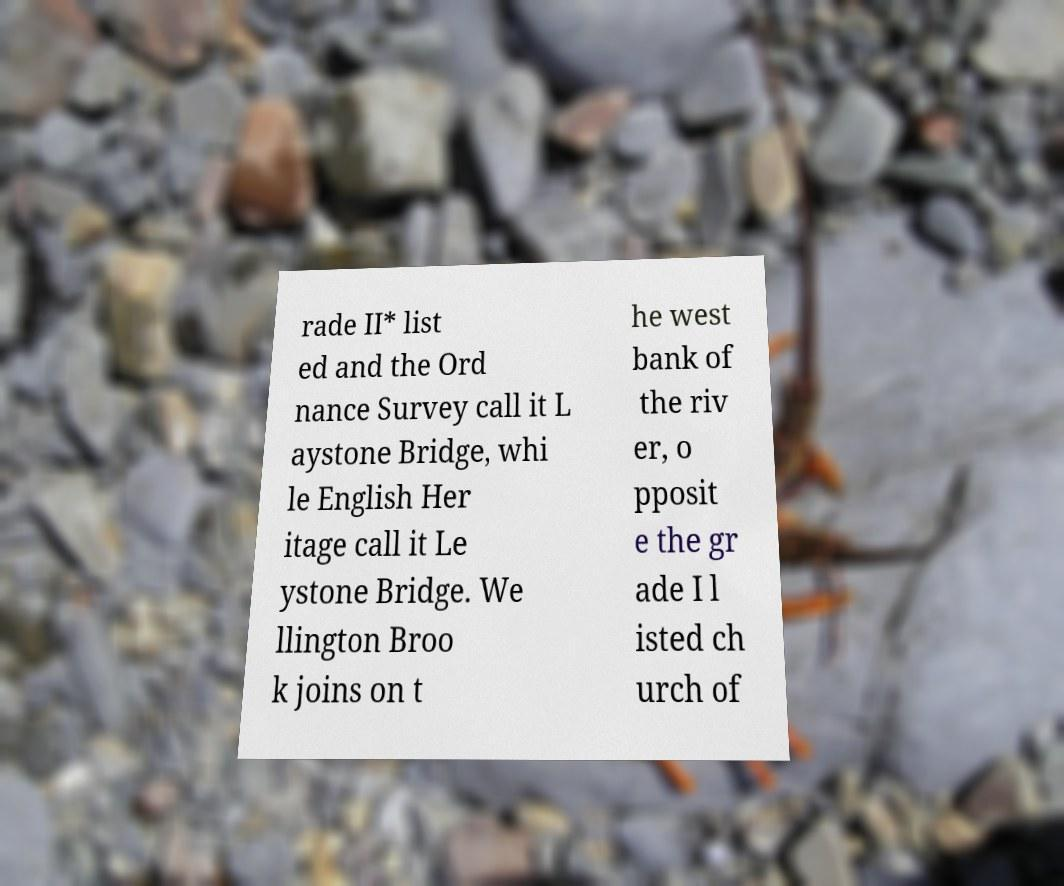Can you accurately transcribe the text from the provided image for me? rade II* list ed and the Ord nance Survey call it L aystone Bridge, whi le English Her itage call it Le ystone Bridge. We llington Broo k joins on t he west bank of the riv er, o pposit e the gr ade I l isted ch urch of 